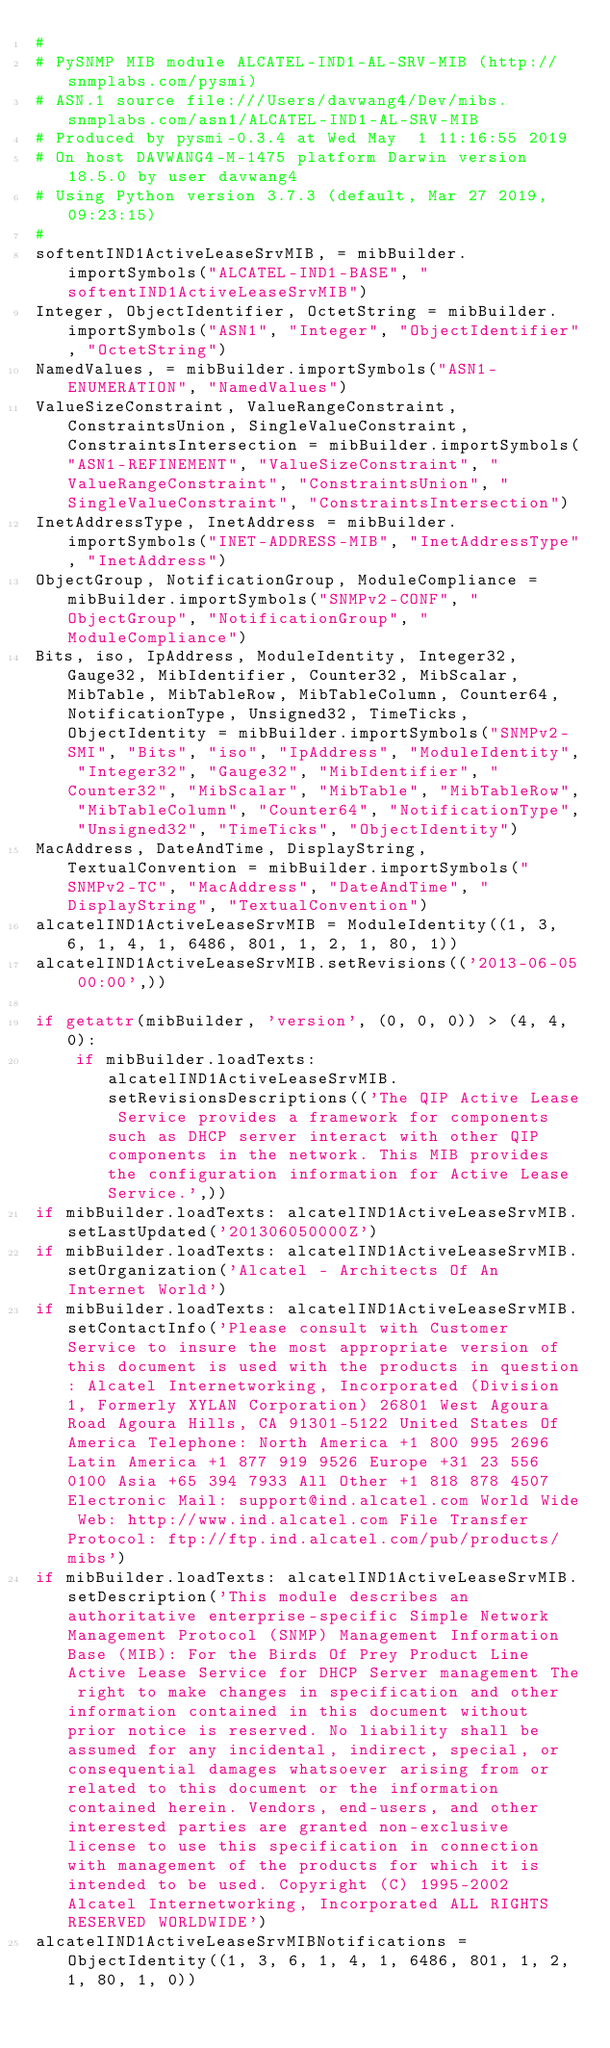<code> <loc_0><loc_0><loc_500><loc_500><_Python_>#
# PySNMP MIB module ALCATEL-IND1-AL-SRV-MIB (http://snmplabs.com/pysmi)
# ASN.1 source file:///Users/davwang4/Dev/mibs.snmplabs.com/asn1/ALCATEL-IND1-AL-SRV-MIB
# Produced by pysmi-0.3.4 at Wed May  1 11:16:55 2019
# On host DAVWANG4-M-1475 platform Darwin version 18.5.0 by user davwang4
# Using Python version 3.7.3 (default, Mar 27 2019, 09:23:15) 
#
softentIND1ActiveLeaseSrvMIB, = mibBuilder.importSymbols("ALCATEL-IND1-BASE", "softentIND1ActiveLeaseSrvMIB")
Integer, ObjectIdentifier, OctetString = mibBuilder.importSymbols("ASN1", "Integer", "ObjectIdentifier", "OctetString")
NamedValues, = mibBuilder.importSymbols("ASN1-ENUMERATION", "NamedValues")
ValueSizeConstraint, ValueRangeConstraint, ConstraintsUnion, SingleValueConstraint, ConstraintsIntersection = mibBuilder.importSymbols("ASN1-REFINEMENT", "ValueSizeConstraint", "ValueRangeConstraint", "ConstraintsUnion", "SingleValueConstraint", "ConstraintsIntersection")
InetAddressType, InetAddress = mibBuilder.importSymbols("INET-ADDRESS-MIB", "InetAddressType", "InetAddress")
ObjectGroup, NotificationGroup, ModuleCompliance = mibBuilder.importSymbols("SNMPv2-CONF", "ObjectGroup", "NotificationGroup", "ModuleCompliance")
Bits, iso, IpAddress, ModuleIdentity, Integer32, Gauge32, MibIdentifier, Counter32, MibScalar, MibTable, MibTableRow, MibTableColumn, Counter64, NotificationType, Unsigned32, TimeTicks, ObjectIdentity = mibBuilder.importSymbols("SNMPv2-SMI", "Bits", "iso", "IpAddress", "ModuleIdentity", "Integer32", "Gauge32", "MibIdentifier", "Counter32", "MibScalar", "MibTable", "MibTableRow", "MibTableColumn", "Counter64", "NotificationType", "Unsigned32", "TimeTicks", "ObjectIdentity")
MacAddress, DateAndTime, DisplayString, TextualConvention = mibBuilder.importSymbols("SNMPv2-TC", "MacAddress", "DateAndTime", "DisplayString", "TextualConvention")
alcatelIND1ActiveLeaseSrvMIB = ModuleIdentity((1, 3, 6, 1, 4, 1, 6486, 801, 1, 2, 1, 80, 1))
alcatelIND1ActiveLeaseSrvMIB.setRevisions(('2013-06-05 00:00',))

if getattr(mibBuilder, 'version', (0, 0, 0)) > (4, 4, 0):
    if mibBuilder.loadTexts: alcatelIND1ActiveLeaseSrvMIB.setRevisionsDescriptions(('The QIP Active Lease Service provides a framework for components such as DHCP server interact with other QIP components in the network. This MIB provides the configuration information for Active Lease Service.',))
if mibBuilder.loadTexts: alcatelIND1ActiveLeaseSrvMIB.setLastUpdated('201306050000Z')
if mibBuilder.loadTexts: alcatelIND1ActiveLeaseSrvMIB.setOrganization('Alcatel - Architects Of An Internet World')
if mibBuilder.loadTexts: alcatelIND1ActiveLeaseSrvMIB.setContactInfo('Please consult with Customer Service to insure the most appropriate version of this document is used with the products in question: Alcatel Internetworking, Incorporated (Division 1, Formerly XYLAN Corporation) 26801 West Agoura Road Agoura Hills, CA 91301-5122 United States Of America Telephone: North America +1 800 995 2696 Latin America +1 877 919 9526 Europe +31 23 556 0100 Asia +65 394 7933 All Other +1 818 878 4507 Electronic Mail: support@ind.alcatel.com World Wide Web: http://www.ind.alcatel.com File Transfer Protocol: ftp://ftp.ind.alcatel.com/pub/products/mibs')
if mibBuilder.loadTexts: alcatelIND1ActiveLeaseSrvMIB.setDescription('This module describes an authoritative enterprise-specific Simple Network Management Protocol (SNMP) Management Information Base (MIB): For the Birds Of Prey Product Line Active Lease Service for DHCP Server management The right to make changes in specification and other information contained in this document without prior notice is reserved. No liability shall be assumed for any incidental, indirect, special, or consequential damages whatsoever arising from or related to this document or the information contained herein. Vendors, end-users, and other interested parties are granted non-exclusive license to use this specification in connection with management of the products for which it is intended to be used. Copyright (C) 1995-2002 Alcatel Internetworking, Incorporated ALL RIGHTS RESERVED WORLDWIDE')
alcatelIND1ActiveLeaseSrvMIBNotifications = ObjectIdentity((1, 3, 6, 1, 4, 1, 6486, 801, 1, 2, 1, 80, 1, 0))</code> 